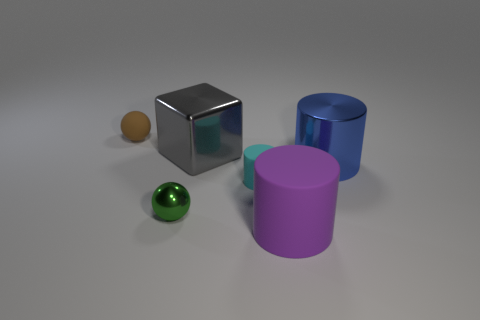Are there the same number of blue metal things left of the big purple cylinder and brown spheres that are right of the blue cylinder?
Give a very brief answer. Yes. Is there a large yellow block made of the same material as the green thing?
Your answer should be very brief. No. Is the green object made of the same material as the purple thing?
Keep it short and to the point. No. How many gray objects are big cubes or large metal things?
Offer a very short reply. 1. Are there more small matte cylinders behind the shiny cylinder than red blocks?
Keep it short and to the point. No. Is there a small cylinder that has the same color as the big shiny cylinder?
Provide a succinct answer. No. How big is the cyan object?
Offer a very short reply. Small. Is the rubber ball the same color as the big matte thing?
Make the answer very short. No. What number of objects are small yellow metal cylinders or rubber things behind the metal cube?
Provide a short and direct response. 1. There is a small matte thing to the left of the ball in front of the gray shiny object; what number of tiny green metal balls are in front of it?
Offer a terse response. 1. 